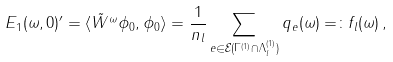<formula> <loc_0><loc_0><loc_500><loc_500>E _ { 1 } ( \omega , 0 ) ^ { \prime } = \langle \tilde { W } ^ { \omega } \phi _ { 0 } , \phi _ { 0 } \rangle = \frac { 1 } { n _ { l } } \sum _ { e \in \mathcal { E } ( \Gamma ^ { ( 1 ) } \cap \Lambda _ { l } ^ { ( 1 ) } ) } q _ { e } ( \omega ) = \colon f _ { l } ( \omega ) \, ,</formula> 